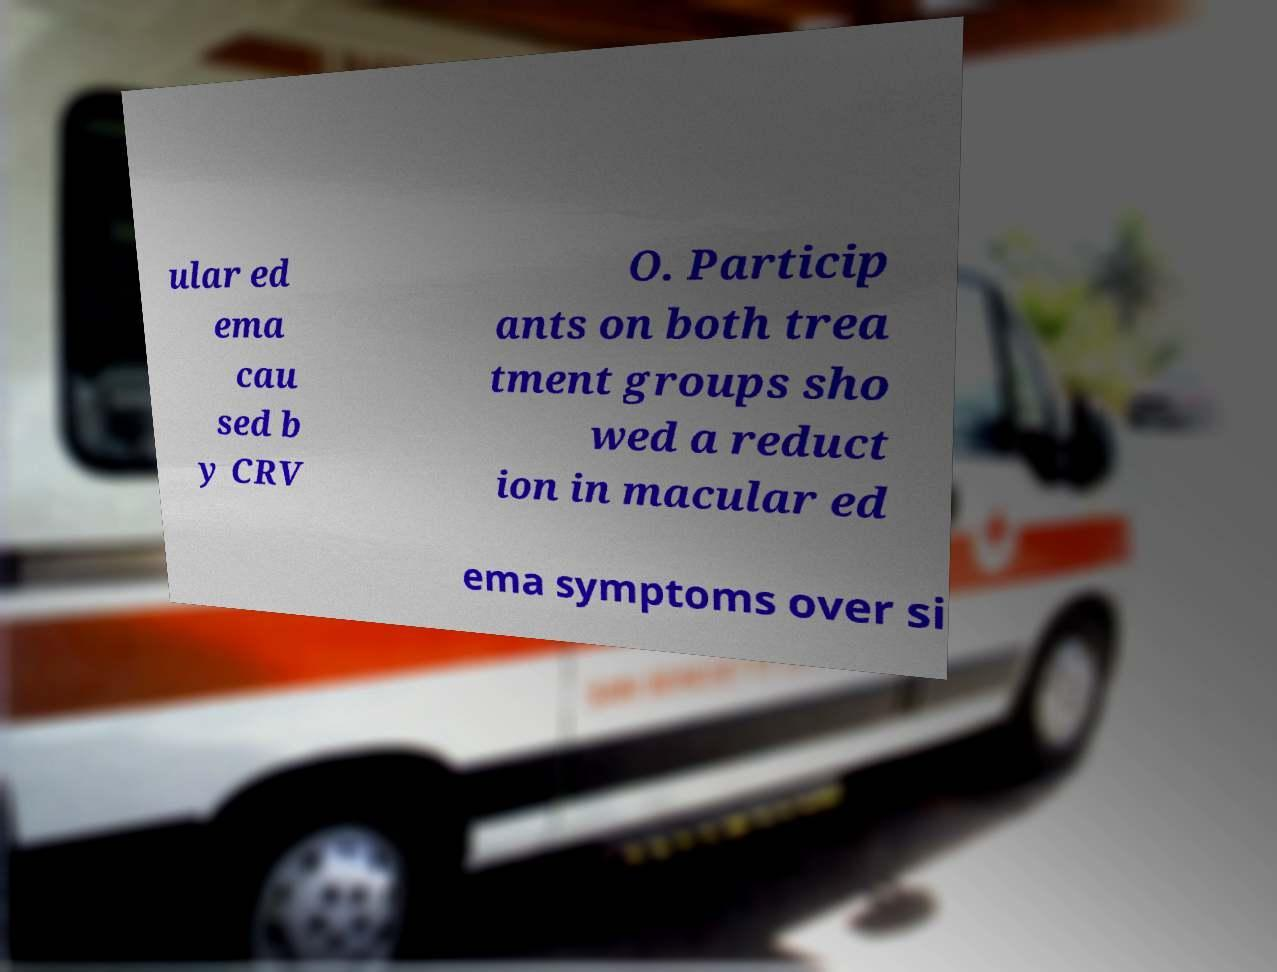Could you assist in decoding the text presented in this image and type it out clearly? ular ed ema cau sed b y CRV O. Particip ants on both trea tment groups sho wed a reduct ion in macular ed ema symptoms over si 